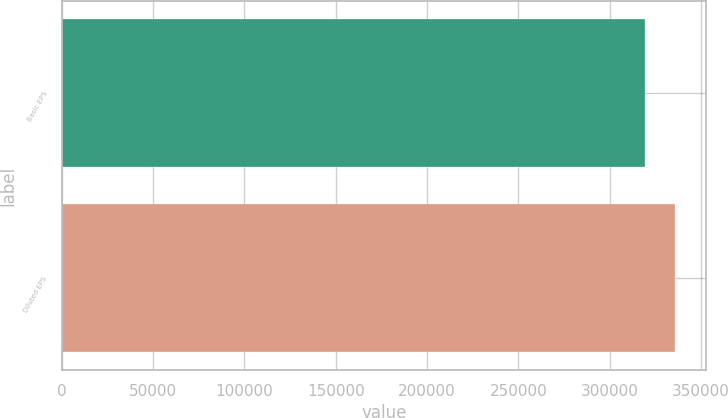Convert chart. <chart><loc_0><loc_0><loc_500><loc_500><bar_chart><fcel>Basic EPS<fcel>Diluted EPS<nl><fcel>319361<fcel>335863<nl></chart> 